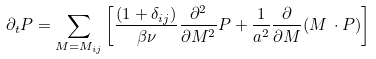Convert formula to latex. <formula><loc_0><loc_0><loc_500><loc_500>\partial _ { t } P = \sum _ { M = M _ { i j } } \left [ { \frac { ( 1 + \delta _ { i j } ) } { \beta \nu } } { \frac { \partial ^ { 2 } } { \partial M ^ { 2 } } } P + { \frac { 1 } { a ^ { 2 } } } { \frac { \partial } { \partial M } } ( M \, \cdot P ) \right ]</formula> 